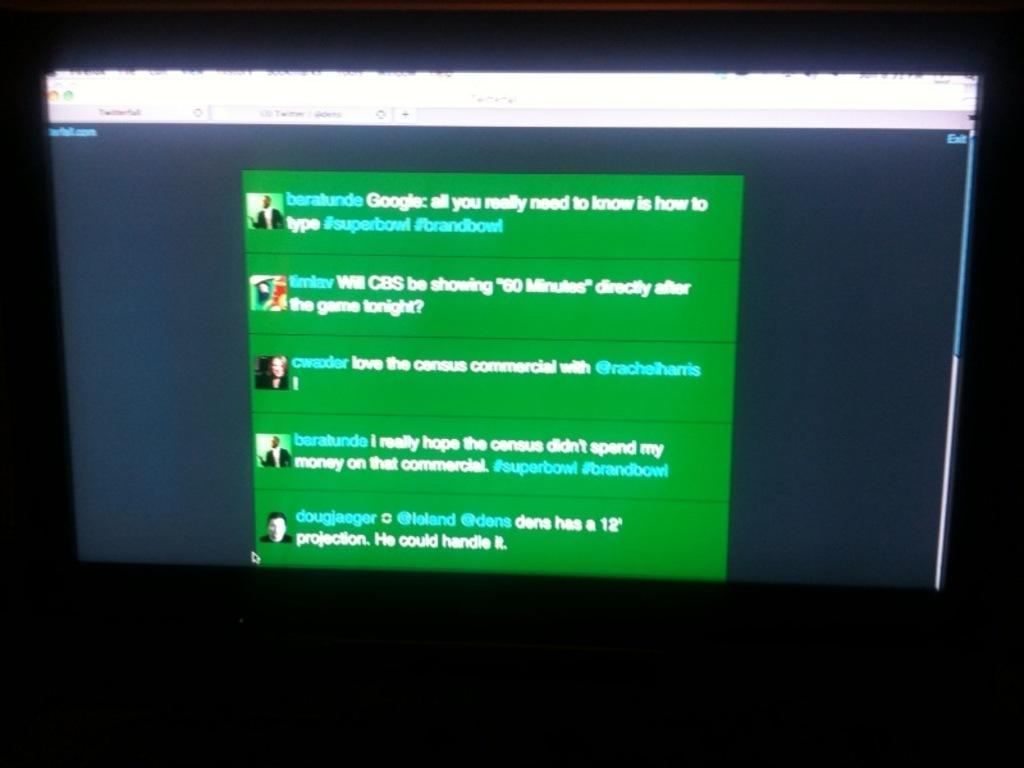<image>
Create a compact narrative representing the image presented. a monitor open to a green screen with words Google on it 